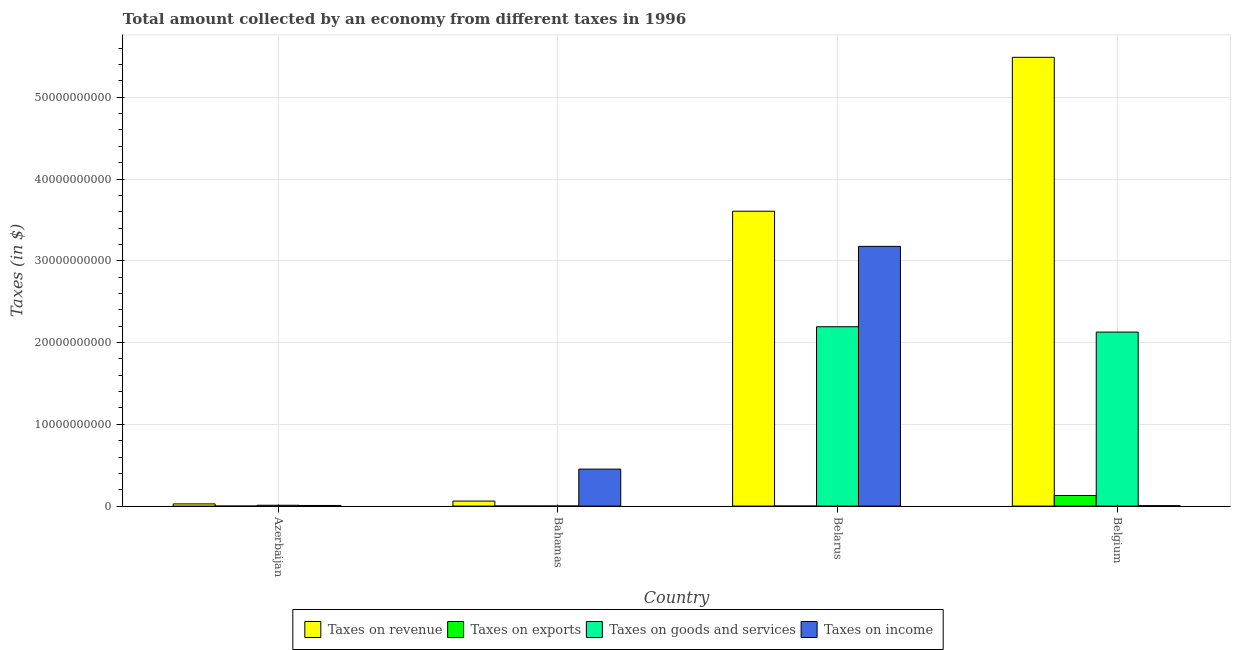How many different coloured bars are there?
Your answer should be very brief. 4. Are the number of bars on each tick of the X-axis equal?
Your answer should be compact. Yes. What is the label of the 2nd group of bars from the left?
Your answer should be compact. Bahamas. In how many cases, is the number of bars for a given country not equal to the number of legend labels?
Offer a very short reply. 0. What is the amount collected as tax on revenue in Belarus?
Give a very brief answer. 3.61e+1. Across all countries, what is the maximum amount collected as tax on revenue?
Offer a very short reply. 5.49e+1. Across all countries, what is the minimum amount collected as tax on goods?
Keep it short and to the point. 1.12e+07. In which country was the amount collected as tax on revenue minimum?
Your answer should be compact. Azerbaijan. What is the total amount collected as tax on revenue in the graph?
Give a very brief answer. 9.18e+1. What is the difference between the amount collected as tax on goods in Belarus and that in Belgium?
Give a very brief answer. 6.51e+08. What is the difference between the amount collected as tax on revenue in Bahamas and the amount collected as tax on exports in Belarus?
Ensure brevity in your answer.  6.15e+08. What is the average amount collected as tax on goods per country?
Your answer should be compact. 1.08e+1. What is the difference between the amount collected as tax on revenue and amount collected as tax on exports in Belarus?
Your answer should be very brief. 3.61e+1. In how many countries, is the amount collected as tax on revenue greater than 26000000000 $?
Make the answer very short. 2. What is the ratio of the amount collected as tax on goods in Bahamas to that in Belgium?
Your answer should be very brief. 0. Is the amount collected as tax on income in Azerbaijan less than that in Belgium?
Keep it short and to the point. No. Is the difference between the amount collected as tax on revenue in Belarus and Belgium greater than the difference between the amount collected as tax on goods in Belarus and Belgium?
Make the answer very short. No. What is the difference between the highest and the second highest amount collected as tax on revenue?
Your response must be concise. 1.88e+1. What is the difference between the highest and the lowest amount collected as tax on exports?
Ensure brevity in your answer.  1.30e+09. In how many countries, is the amount collected as tax on income greater than the average amount collected as tax on income taken over all countries?
Offer a terse response. 1. Is the sum of the amount collected as tax on goods in Belarus and Belgium greater than the maximum amount collected as tax on revenue across all countries?
Provide a short and direct response. No. What does the 1st bar from the left in Bahamas represents?
Offer a terse response. Taxes on revenue. What does the 2nd bar from the right in Belgium represents?
Ensure brevity in your answer.  Taxes on goods and services. Is it the case that in every country, the sum of the amount collected as tax on revenue and amount collected as tax on exports is greater than the amount collected as tax on goods?
Provide a short and direct response. Yes. Are all the bars in the graph horizontal?
Ensure brevity in your answer.  No. How many countries are there in the graph?
Offer a very short reply. 4. What is the difference between two consecutive major ticks on the Y-axis?
Provide a short and direct response. 1.00e+1. Does the graph contain any zero values?
Provide a succinct answer. No. Does the graph contain grids?
Give a very brief answer. Yes. Where does the legend appear in the graph?
Give a very brief answer. Bottom center. How many legend labels are there?
Provide a succinct answer. 4. How are the legend labels stacked?
Offer a terse response. Horizontal. What is the title of the graph?
Keep it short and to the point. Total amount collected by an economy from different taxes in 1996. What is the label or title of the Y-axis?
Provide a succinct answer. Taxes (in $). What is the Taxes (in $) of Taxes on revenue in Azerbaijan?
Provide a short and direct response. 2.69e+08. What is the Taxes (in $) in Taxes on exports in Azerbaijan?
Your answer should be compact. 1.20e+04. What is the Taxes (in $) of Taxes on goods and services in Azerbaijan?
Your answer should be very brief. 1.05e+08. What is the Taxes (in $) of Taxes on income in Azerbaijan?
Offer a terse response. 7.65e+07. What is the Taxes (in $) of Taxes on revenue in Bahamas?
Give a very brief answer. 6.15e+08. What is the Taxes (in $) of Taxes on exports in Bahamas?
Your answer should be very brief. 1.14e+07. What is the Taxes (in $) in Taxes on goods and services in Bahamas?
Offer a terse response. 1.12e+07. What is the Taxes (in $) in Taxes on income in Bahamas?
Offer a very short reply. 4.52e+09. What is the Taxes (in $) of Taxes on revenue in Belarus?
Your answer should be compact. 3.61e+1. What is the Taxes (in $) in Taxes on exports in Belarus?
Ensure brevity in your answer.  3.00e+05. What is the Taxes (in $) of Taxes on goods and services in Belarus?
Offer a very short reply. 2.19e+1. What is the Taxes (in $) in Taxes on income in Belarus?
Your response must be concise. 3.18e+1. What is the Taxes (in $) of Taxes on revenue in Belgium?
Make the answer very short. 5.49e+1. What is the Taxes (in $) of Taxes on exports in Belgium?
Your answer should be very brief. 1.30e+09. What is the Taxes (in $) of Taxes on goods and services in Belgium?
Your answer should be very brief. 2.13e+1. What is the Taxes (in $) of Taxes on income in Belgium?
Ensure brevity in your answer.  5.19e+07. Across all countries, what is the maximum Taxes (in $) in Taxes on revenue?
Ensure brevity in your answer.  5.49e+1. Across all countries, what is the maximum Taxes (in $) in Taxes on exports?
Ensure brevity in your answer.  1.30e+09. Across all countries, what is the maximum Taxes (in $) in Taxes on goods and services?
Your response must be concise. 2.19e+1. Across all countries, what is the maximum Taxes (in $) in Taxes on income?
Provide a short and direct response. 3.18e+1. Across all countries, what is the minimum Taxes (in $) in Taxes on revenue?
Offer a very short reply. 2.69e+08. Across all countries, what is the minimum Taxes (in $) of Taxes on exports?
Your answer should be very brief. 1.20e+04. Across all countries, what is the minimum Taxes (in $) in Taxes on goods and services?
Your response must be concise. 1.12e+07. Across all countries, what is the minimum Taxes (in $) of Taxes on income?
Your response must be concise. 5.19e+07. What is the total Taxes (in $) in Taxes on revenue in the graph?
Provide a succinct answer. 9.18e+1. What is the total Taxes (in $) of Taxes on exports in the graph?
Ensure brevity in your answer.  1.31e+09. What is the total Taxes (in $) of Taxes on goods and services in the graph?
Offer a terse response. 4.33e+1. What is the total Taxes (in $) of Taxes on income in the graph?
Make the answer very short. 3.64e+1. What is the difference between the Taxes (in $) in Taxes on revenue in Azerbaijan and that in Bahamas?
Offer a terse response. -3.46e+08. What is the difference between the Taxes (in $) of Taxes on exports in Azerbaijan and that in Bahamas?
Your response must be concise. -1.14e+07. What is the difference between the Taxes (in $) of Taxes on goods and services in Azerbaijan and that in Bahamas?
Make the answer very short. 9.38e+07. What is the difference between the Taxes (in $) of Taxes on income in Azerbaijan and that in Bahamas?
Provide a short and direct response. -4.45e+09. What is the difference between the Taxes (in $) of Taxes on revenue in Azerbaijan and that in Belarus?
Give a very brief answer. -3.58e+1. What is the difference between the Taxes (in $) of Taxes on exports in Azerbaijan and that in Belarus?
Provide a succinct answer. -2.88e+05. What is the difference between the Taxes (in $) in Taxes on goods and services in Azerbaijan and that in Belarus?
Your answer should be compact. -2.18e+1. What is the difference between the Taxes (in $) in Taxes on income in Azerbaijan and that in Belarus?
Offer a very short reply. -3.17e+1. What is the difference between the Taxes (in $) of Taxes on revenue in Azerbaijan and that in Belgium?
Make the answer very short. -5.46e+1. What is the difference between the Taxes (in $) of Taxes on exports in Azerbaijan and that in Belgium?
Your answer should be compact. -1.30e+09. What is the difference between the Taxes (in $) of Taxes on goods and services in Azerbaijan and that in Belgium?
Your response must be concise. -2.12e+1. What is the difference between the Taxes (in $) of Taxes on income in Azerbaijan and that in Belgium?
Give a very brief answer. 2.46e+07. What is the difference between the Taxes (in $) in Taxes on revenue in Bahamas and that in Belarus?
Provide a succinct answer. -3.54e+1. What is the difference between the Taxes (in $) in Taxes on exports in Bahamas and that in Belarus?
Your response must be concise. 1.11e+07. What is the difference between the Taxes (in $) in Taxes on goods and services in Bahamas and that in Belarus?
Ensure brevity in your answer.  -2.19e+1. What is the difference between the Taxes (in $) of Taxes on income in Bahamas and that in Belarus?
Your response must be concise. -2.72e+1. What is the difference between the Taxes (in $) of Taxes on revenue in Bahamas and that in Belgium?
Ensure brevity in your answer.  -5.43e+1. What is the difference between the Taxes (in $) of Taxes on exports in Bahamas and that in Belgium?
Make the answer very short. -1.29e+09. What is the difference between the Taxes (in $) in Taxes on goods and services in Bahamas and that in Belgium?
Offer a terse response. -2.13e+1. What is the difference between the Taxes (in $) in Taxes on income in Bahamas and that in Belgium?
Your answer should be compact. 4.47e+09. What is the difference between the Taxes (in $) in Taxes on revenue in Belarus and that in Belgium?
Provide a succinct answer. -1.88e+1. What is the difference between the Taxes (in $) in Taxes on exports in Belarus and that in Belgium?
Give a very brief answer. -1.30e+09. What is the difference between the Taxes (in $) of Taxes on goods and services in Belarus and that in Belgium?
Ensure brevity in your answer.  6.51e+08. What is the difference between the Taxes (in $) in Taxes on income in Belarus and that in Belgium?
Your answer should be very brief. 3.17e+1. What is the difference between the Taxes (in $) in Taxes on revenue in Azerbaijan and the Taxes (in $) in Taxes on exports in Bahamas?
Make the answer very short. 2.58e+08. What is the difference between the Taxes (in $) in Taxes on revenue in Azerbaijan and the Taxes (in $) in Taxes on goods and services in Bahamas?
Your response must be concise. 2.58e+08. What is the difference between the Taxes (in $) of Taxes on revenue in Azerbaijan and the Taxes (in $) of Taxes on income in Bahamas?
Your answer should be compact. -4.25e+09. What is the difference between the Taxes (in $) in Taxes on exports in Azerbaijan and the Taxes (in $) in Taxes on goods and services in Bahamas?
Ensure brevity in your answer.  -1.12e+07. What is the difference between the Taxes (in $) in Taxes on exports in Azerbaijan and the Taxes (in $) in Taxes on income in Bahamas?
Provide a short and direct response. -4.52e+09. What is the difference between the Taxes (in $) of Taxes on goods and services in Azerbaijan and the Taxes (in $) of Taxes on income in Bahamas?
Make the answer very short. -4.42e+09. What is the difference between the Taxes (in $) in Taxes on revenue in Azerbaijan and the Taxes (in $) in Taxes on exports in Belarus?
Ensure brevity in your answer.  2.69e+08. What is the difference between the Taxes (in $) of Taxes on revenue in Azerbaijan and the Taxes (in $) of Taxes on goods and services in Belarus?
Give a very brief answer. -2.17e+1. What is the difference between the Taxes (in $) in Taxes on revenue in Azerbaijan and the Taxes (in $) in Taxes on income in Belarus?
Offer a terse response. -3.15e+1. What is the difference between the Taxes (in $) of Taxes on exports in Azerbaijan and the Taxes (in $) of Taxes on goods and services in Belarus?
Your answer should be very brief. -2.19e+1. What is the difference between the Taxes (in $) in Taxes on exports in Azerbaijan and the Taxes (in $) in Taxes on income in Belarus?
Ensure brevity in your answer.  -3.18e+1. What is the difference between the Taxes (in $) of Taxes on goods and services in Azerbaijan and the Taxes (in $) of Taxes on income in Belarus?
Your answer should be very brief. -3.17e+1. What is the difference between the Taxes (in $) of Taxes on revenue in Azerbaijan and the Taxes (in $) of Taxes on exports in Belgium?
Offer a terse response. -1.03e+09. What is the difference between the Taxes (in $) of Taxes on revenue in Azerbaijan and the Taxes (in $) of Taxes on goods and services in Belgium?
Keep it short and to the point. -2.10e+1. What is the difference between the Taxes (in $) in Taxes on revenue in Azerbaijan and the Taxes (in $) in Taxes on income in Belgium?
Keep it short and to the point. 2.17e+08. What is the difference between the Taxes (in $) of Taxes on exports in Azerbaijan and the Taxes (in $) of Taxes on goods and services in Belgium?
Keep it short and to the point. -2.13e+1. What is the difference between the Taxes (in $) of Taxes on exports in Azerbaijan and the Taxes (in $) of Taxes on income in Belgium?
Provide a succinct answer. -5.19e+07. What is the difference between the Taxes (in $) in Taxes on goods and services in Azerbaijan and the Taxes (in $) in Taxes on income in Belgium?
Make the answer very short. 5.31e+07. What is the difference between the Taxes (in $) of Taxes on revenue in Bahamas and the Taxes (in $) of Taxes on exports in Belarus?
Offer a very short reply. 6.15e+08. What is the difference between the Taxes (in $) of Taxes on revenue in Bahamas and the Taxes (in $) of Taxes on goods and services in Belarus?
Provide a succinct answer. -2.13e+1. What is the difference between the Taxes (in $) in Taxes on revenue in Bahamas and the Taxes (in $) in Taxes on income in Belarus?
Your response must be concise. -3.11e+1. What is the difference between the Taxes (in $) of Taxes on exports in Bahamas and the Taxes (in $) of Taxes on goods and services in Belarus?
Keep it short and to the point. -2.19e+1. What is the difference between the Taxes (in $) in Taxes on exports in Bahamas and the Taxes (in $) in Taxes on income in Belarus?
Offer a terse response. -3.18e+1. What is the difference between the Taxes (in $) of Taxes on goods and services in Bahamas and the Taxes (in $) of Taxes on income in Belarus?
Provide a succinct answer. -3.18e+1. What is the difference between the Taxes (in $) in Taxes on revenue in Bahamas and the Taxes (in $) in Taxes on exports in Belgium?
Give a very brief answer. -6.83e+08. What is the difference between the Taxes (in $) in Taxes on revenue in Bahamas and the Taxes (in $) in Taxes on goods and services in Belgium?
Offer a very short reply. -2.07e+1. What is the difference between the Taxes (in $) of Taxes on revenue in Bahamas and the Taxes (in $) of Taxes on income in Belgium?
Offer a terse response. 5.63e+08. What is the difference between the Taxes (in $) of Taxes on exports in Bahamas and the Taxes (in $) of Taxes on goods and services in Belgium?
Offer a terse response. -2.13e+1. What is the difference between the Taxes (in $) of Taxes on exports in Bahamas and the Taxes (in $) of Taxes on income in Belgium?
Provide a short and direct response. -4.05e+07. What is the difference between the Taxes (in $) of Taxes on goods and services in Bahamas and the Taxes (in $) of Taxes on income in Belgium?
Provide a short and direct response. -4.07e+07. What is the difference between the Taxes (in $) in Taxes on revenue in Belarus and the Taxes (in $) in Taxes on exports in Belgium?
Make the answer very short. 3.48e+1. What is the difference between the Taxes (in $) of Taxes on revenue in Belarus and the Taxes (in $) of Taxes on goods and services in Belgium?
Your answer should be very brief. 1.48e+1. What is the difference between the Taxes (in $) in Taxes on revenue in Belarus and the Taxes (in $) in Taxes on income in Belgium?
Offer a terse response. 3.60e+1. What is the difference between the Taxes (in $) of Taxes on exports in Belarus and the Taxes (in $) of Taxes on goods and services in Belgium?
Offer a terse response. -2.13e+1. What is the difference between the Taxes (in $) in Taxes on exports in Belarus and the Taxes (in $) in Taxes on income in Belgium?
Provide a succinct answer. -5.16e+07. What is the difference between the Taxes (in $) of Taxes on goods and services in Belarus and the Taxes (in $) of Taxes on income in Belgium?
Make the answer very short. 2.19e+1. What is the average Taxes (in $) in Taxes on revenue per country?
Your answer should be compact. 2.30e+1. What is the average Taxes (in $) in Taxes on exports per country?
Provide a succinct answer. 3.27e+08. What is the average Taxes (in $) in Taxes on goods and services per country?
Your answer should be very brief. 1.08e+1. What is the average Taxes (in $) of Taxes on income per country?
Provide a succinct answer. 9.10e+09. What is the difference between the Taxes (in $) in Taxes on revenue and Taxes (in $) in Taxes on exports in Azerbaijan?
Give a very brief answer. 2.69e+08. What is the difference between the Taxes (in $) in Taxes on revenue and Taxes (in $) in Taxes on goods and services in Azerbaijan?
Your answer should be very brief. 1.64e+08. What is the difference between the Taxes (in $) of Taxes on revenue and Taxes (in $) of Taxes on income in Azerbaijan?
Offer a terse response. 1.93e+08. What is the difference between the Taxes (in $) of Taxes on exports and Taxes (in $) of Taxes on goods and services in Azerbaijan?
Offer a terse response. -1.05e+08. What is the difference between the Taxes (in $) in Taxes on exports and Taxes (in $) in Taxes on income in Azerbaijan?
Ensure brevity in your answer.  -7.65e+07. What is the difference between the Taxes (in $) of Taxes on goods and services and Taxes (in $) of Taxes on income in Azerbaijan?
Offer a very short reply. 2.85e+07. What is the difference between the Taxes (in $) of Taxes on revenue and Taxes (in $) of Taxes on exports in Bahamas?
Give a very brief answer. 6.04e+08. What is the difference between the Taxes (in $) in Taxes on revenue and Taxes (in $) in Taxes on goods and services in Bahamas?
Offer a very short reply. 6.04e+08. What is the difference between the Taxes (in $) in Taxes on revenue and Taxes (in $) in Taxes on income in Bahamas?
Provide a succinct answer. -3.91e+09. What is the difference between the Taxes (in $) of Taxes on exports and Taxes (in $) of Taxes on income in Bahamas?
Ensure brevity in your answer.  -4.51e+09. What is the difference between the Taxes (in $) in Taxes on goods and services and Taxes (in $) in Taxes on income in Bahamas?
Your response must be concise. -4.51e+09. What is the difference between the Taxes (in $) in Taxes on revenue and Taxes (in $) in Taxes on exports in Belarus?
Provide a short and direct response. 3.61e+1. What is the difference between the Taxes (in $) of Taxes on revenue and Taxes (in $) of Taxes on goods and services in Belarus?
Make the answer very short. 1.41e+1. What is the difference between the Taxes (in $) of Taxes on revenue and Taxes (in $) of Taxes on income in Belarus?
Keep it short and to the point. 4.30e+09. What is the difference between the Taxes (in $) of Taxes on exports and Taxes (in $) of Taxes on goods and services in Belarus?
Give a very brief answer. -2.19e+1. What is the difference between the Taxes (in $) of Taxes on exports and Taxes (in $) of Taxes on income in Belarus?
Provide a succinct answer. -3.18e+1. What is the difference between the Taxes (in $) in Taxes on goods and services and Taxes (in $) in Taxes on income in Belarus?
Give a very brief answer. -9.83e+09. What is the difference between the Taxes (in $) of Taxes on revenue and Taxes (in $) of Taxes on exports in Belgium?
Make the answer very short. 5.36e+1. What is the difference between the Taxes (in $) in Taxes on revenue and Taxes (in $) in Taxes on goods and services in Belgium?
Provide a short and direct response. 3.36e+1. What is the difference between the Taxes (in $) of Taxes on revenue and Taxes (in $) of Taxes on income in Belgium?
Keep it short and to the point. 5.48e+1. What is the difference between the Taxes (in $) of Taxes on exports and Taxes (in $) of Taxes on goods and services in Belgium?
Your answer should be compact. -2.00e+1. What is the difference between the Taxes (in $) of Taxes on exports and Taxes (in $) of Taxes on income in Belgium?
Your response must be concise. 1.25e+09. What is the difference between the Taxes (in $) in Taxes on goods and services and Taxes (in $) in Taxes on income in Belgium?
Ensure brevity in your answer.  2.12e+1. What is the ratio of the Taxes (in $) in Taxes on revenue in Azerbaijan to that in Bahamas?
Your answer should be very brief. 0.44. What is the ratio of the Taxes (in $) in Taxes on exports in Azerbaijan to that in Bahamas?
Keep it short and to the point. 0. What is the ratio of the Taxes (in $) of Taxes on goods and services in Azerbaijan to that in Bahamas?
Provide a short and direct response. 9.38. What is the ratio of the Taxes (in $) of Taxes on income in Azerbaijan to that in Bahamas?
Ensure brevity in your answer.  0.02. What is the ratio of the Taxes (in $) in Taxes on revenue in Azerbaijan to that in Belarus?
Give a very brief answer. 0.01. What is the ratio of the Taxes (in $) in Taxes on goods and services in Azerbaijan to that in Belarus?
Give a very brief answer. 0. What is the ratio of the Taxes (in $) in Taxes on income in Azerbaijan to that in Belarus?
Make the answer very short. 0. What is the ratio of the Taxes (in $) of Taxes on revenue in Azerbaijan to that in Belgium?
Give a very brief answer. 0. What is the ratio of the Taxes (in $) of Taxes on goods and services in Azerbaijan to that in Belgium?
Keep it short and to the point. 0. What is the ratio of the Taxes (in $) of Taxes on income in Azerbaijan to that in Belgium?
Provide a short and direct response. 1.47. What is the ratio of the Taxes (in $) in Taxes on revenue in Bahamas to that in Belarus?
Your answer should be compact. 0.02. What is the ratio of the Taxes (in $) in Taxes on exports in Bahamas to that in Belarus?
Provide a succinct answer. 38. What is the ratio of the Taxes (in $) of Taxes on goods and services in Bahamas to that in Belarus?
Your response must be concise. 0. What is the ratio of the Taxes (in $) of Taxes on income in Bahamas to that in Belarus?
Your response must be concise. 0.14. What is the ratio of the Taxes (in $) of Taxes on revenue in Bahamas to that in Belgium?
Ensure brevity in your answer.  0.01. What is the ratio of the Taxes (in $) in Taxes on exports in Bahamas to that in Belgium?
Offer a terse response. 0.01. What is the ratio of the Taxes (in $) in Taxes on income in Bahamas to that in Belgium?
Offer a very short reply. 87.18. What is the ratio of the Taxes (in $) of Taxes on revenue in Belarus to that in Belgium?
Give a very brief answer. 0.66. What is the ratio of the Taxes (in $) in Taxes on exports in Belarus to that in Belgium?
Ensure brevity in your answer.  0. What is the ratio of the Taxes (in $) in Taxes on goods and services in Belarus to that in Belgium?
Ensure brevity in your answer.  1.03. What is the ratio of the Taxes (in $) of Taxes on income in Belarus to that in Belgium?
Offer a terse response. 612.24. What is the difference between the highest and the second highest Taxes (in $) in Taxes on revenue?
Make the answer very short. 1.88e+1. What is the difference between the highest and the second highest Taxes (in $) of Taxes on exports?
Offer a very short reply. 1.29e+09. What is the difference between the highest and the second highest Taxes (in $) of Taxes on goods and services?
Your answer should be very brief. 6.51e+08. What is the difference between the highest and the second highest Taxes (in $) in Taxes on income?
Offer a very short reply. 2.72e+1. What is the difference between the highest and the lowest Taxes (in $) in Taxes on revenue?
Your answer should be very brief. 5.46e+1. What is the difference between the highest and the lowest Taxes (in $) of Taxes on exports?
Offer a terse response. 1.30e+09. What is the difference between the highest and the lowest Taxes (in $) in Taxes on goods and services?
Your response must be concise. 2.19e+1. What is the difference between the highest and the lowest Taxes (in $) of Taxes on income?
Your response must be concise. 3.17e+1. 